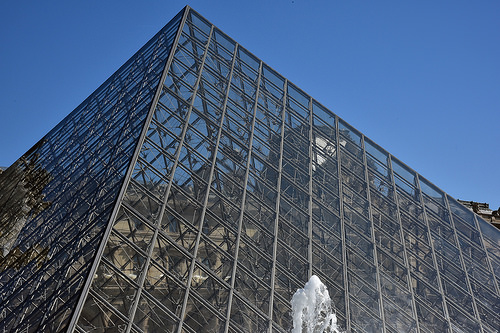<image>
Is the fountain on the building? No. The fountain is not positioned on the building. They may be near each other, but the fountain is not supported by or resting on top of the building. 